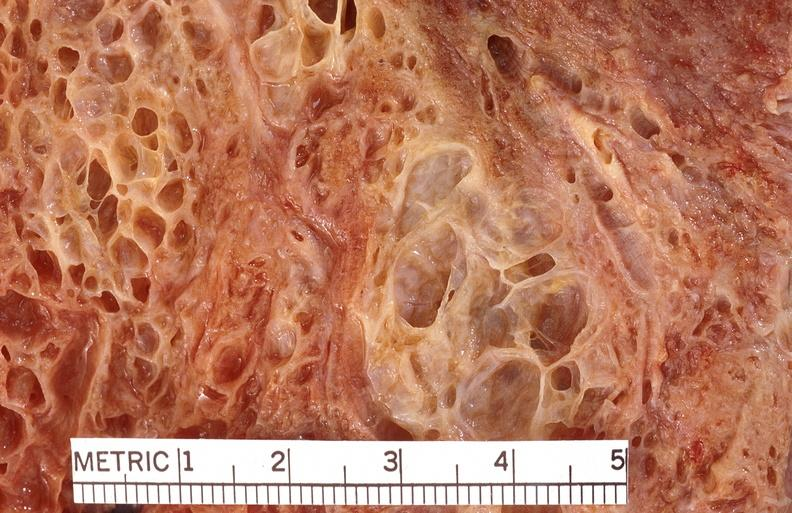where is this?
Answer the question using a single word or phrase. Lung 